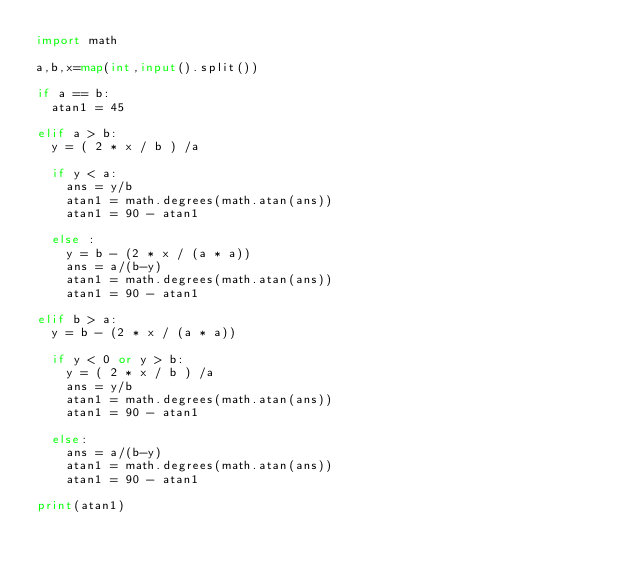<code> <loc_0><loc_0><loc_500><loc_500><_Python_>import math

a,b,x=map(int,input().split())

if a == b:
  atan1 = 45
  
elif a > b:
  y = ( 2 * x / b ) /a
 
  if y < a:
    ans = y/b
    atan1 = math.degrees(math.atan(ans))
    atan1 = 90 - atan1
    
  else :
    y = b - (2 * x / (a * a))
    ans = a/(b-y)
    atan1 = math.degrees(math.atan(ans))
    atan1 = 90 - atan1
  
elif b > a:
  y = b - (2 * x / (a * a))
  
  if y < 0 or y > b:
    y = ( 2 * x / b ) /a
    ans = y/b
    atan1 = math.degrees(math.atan(ans))
    atan1 = 90 - atan1
    
  else:
    ans = a/(b-y)
    atan1 = math.degrees(math.atan(ans))
    atan1 = 90 - atan1
  
print(atan1)
</code> 